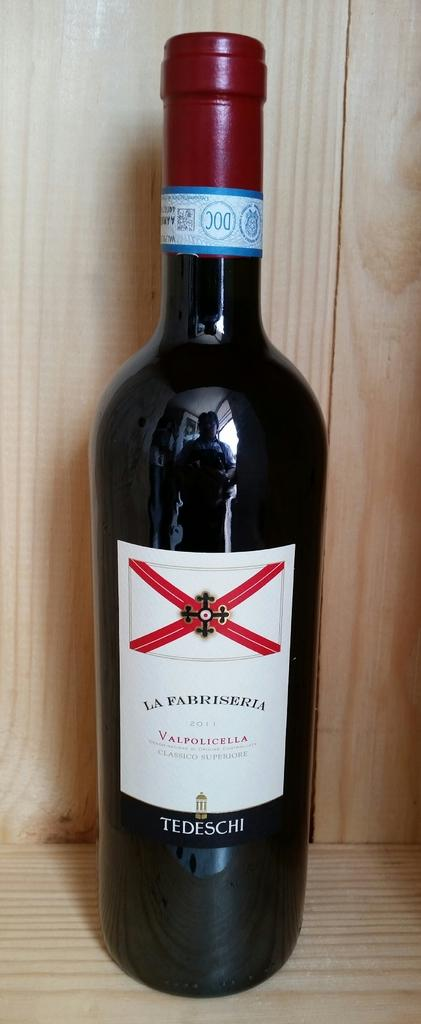Provide a one-sentence caption for the provided image. A bottle of La Fabriseria wine made in 2011 made by Tedeschi wines. 